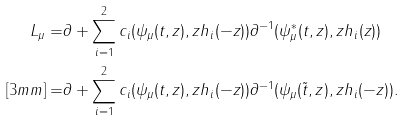<formula> <loc_0><loc_0><loc_500><loc_500>L _ { \mu } = & \partial + \sum _ { i = 1 } ^ { 2 } c _ { i } ( \psi _ { \mu } ( t , z ) , z h _ { i } ( - z ) ) \partial ^ { - 1 } ( \psi _ { \mu } ^ { * } ( t , z ) , z h _ { i } ( z ) ) \\ [ 3 m m ] = & \partial + \sum _ { i = 1 } ^ { 2 } c _ { i } ( \psi _ { \mu } ( t , z ) , z h _ { i } ( - z ) ) \partial ^ { - 1 } ( \psi _ { \mu } ( \tilde { t } , z ) , z h _ { i } ( - z ) ) .</formula> 